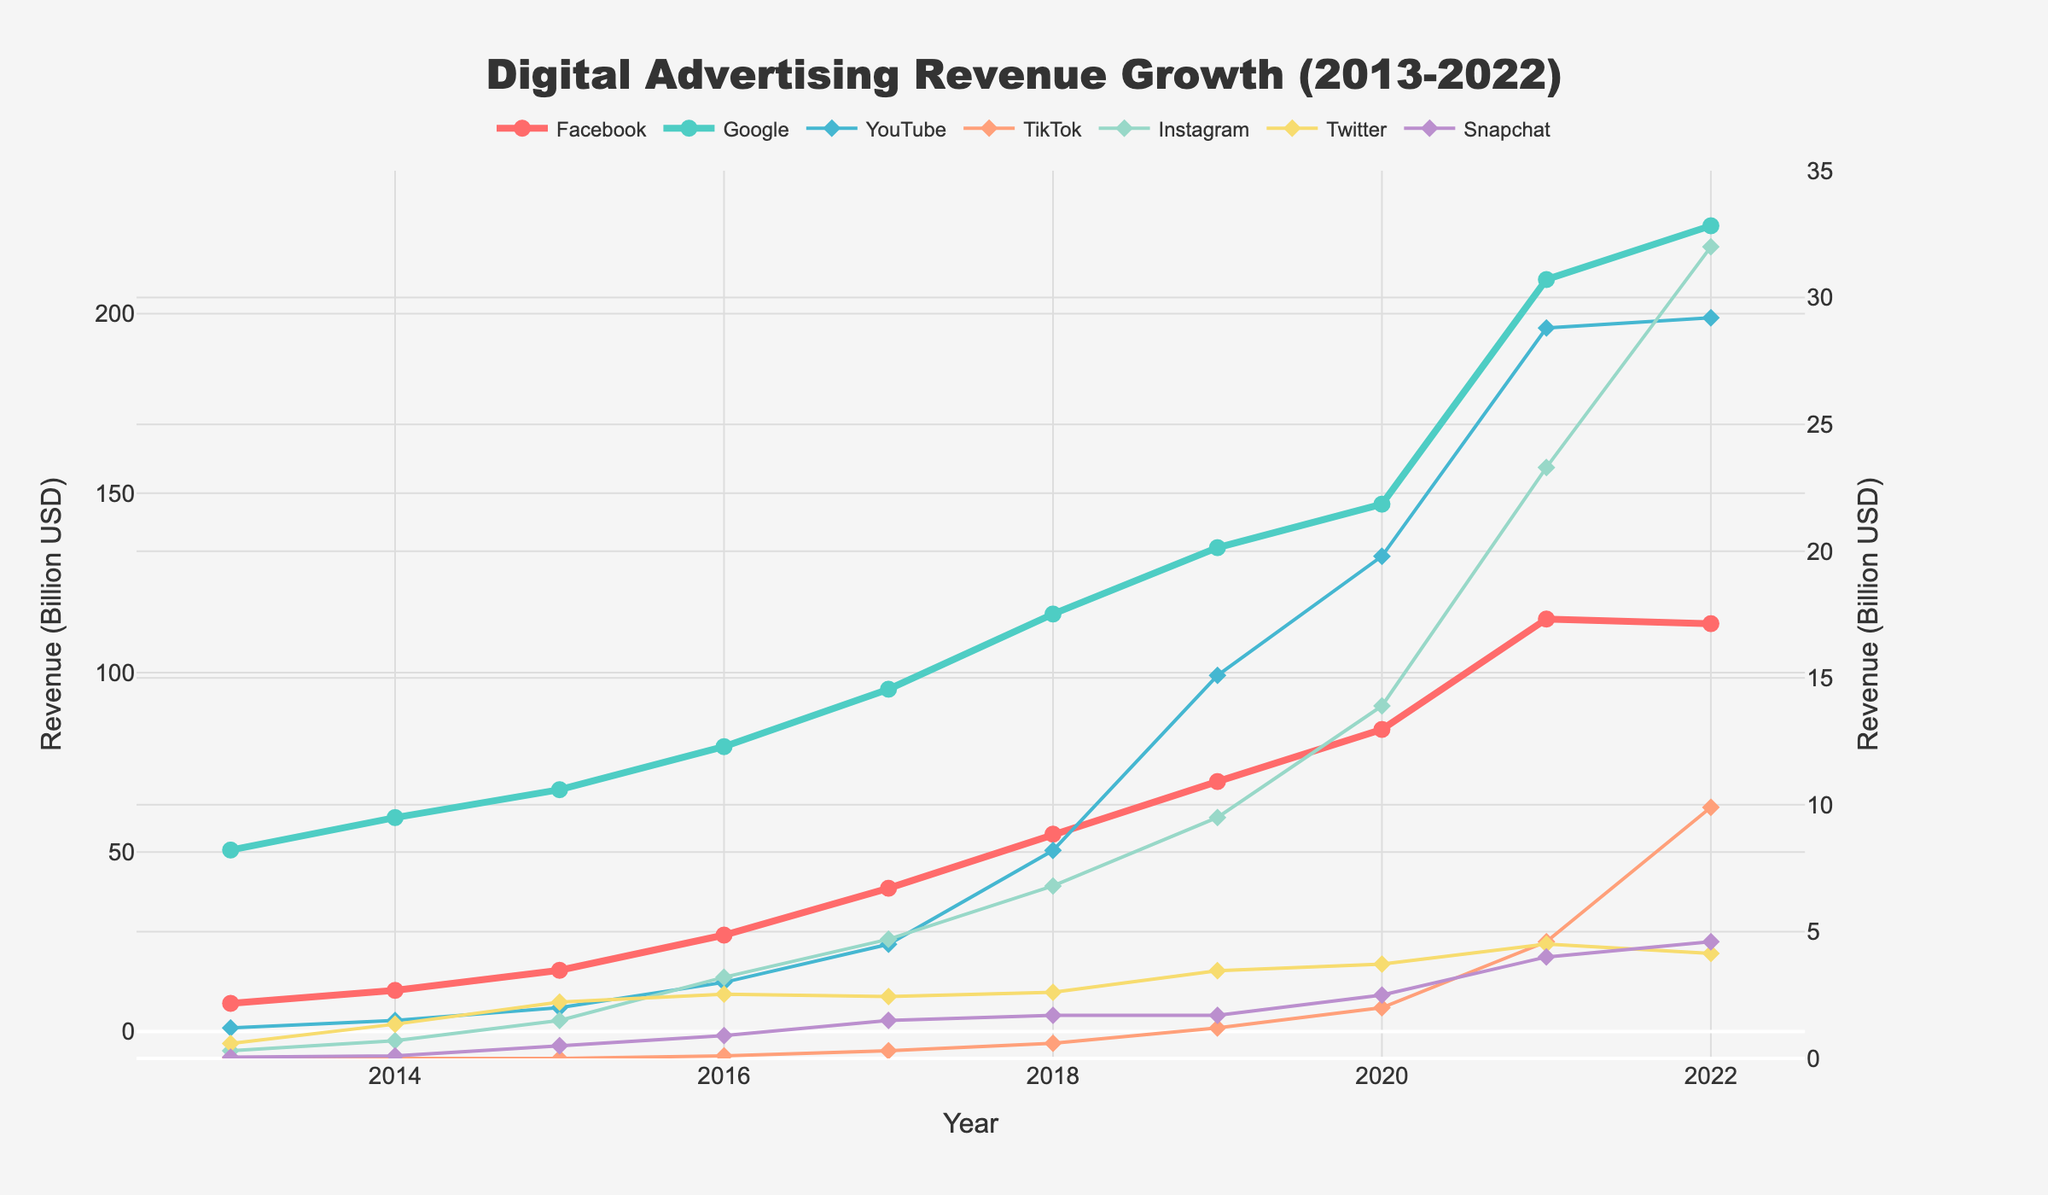Which platform had the highest digital advertising revenue in 2021? Look for the year 2021 on the x-axis and then check which platform has the highest y-value at that point. The highest peak corresponds to Google.
Answer: Google Between which years did Facebook see the highest increase in revenue? Observe the slope of the lines for Facebook; the steepest slope indicates the highest increase, which occurs between 2020 and 2021.
Answer: 2020-2021 What is the difference in revenue between Instagram and TikTok in 2022? Identify the y-values for Instagram and TikTok in 2022 and subtract TikTok's value from Instagram's value. Instagram has approximately 32 billion USD, and TikTok has 9.9 billion USD; the difference is 32 - 9.9.
Answer: 22.1 billion USD In which years did Google's revenue increase less than Facebook's? Compare the slopes of the lines for Google and Facebook for each year. Google's revenue increased less than Facebook's in 2013, 2014, 2015, and 2022.
Answer: 2013, 2014, 2015, 2022 What is the average revenue of Snapchat over the last decade? Sum the revenue values for Snapchat from 2013 to 2022 and divide by the number of years (10). (0.05 + 0.1 + 0.5 + 0.9 + 1.5 + 1.7 + 1.7 + 2.5 + 4.0 + 4.6) / 10 = 1.63 billion USD.
Answer: 1.63 billion USD Which platform showed consistent growth without any drop in revenue from 2013 to 2022? Follow the lines for all platforms and confirm the one that continuously increases. Facebook's line consistently rises throughout the period.
Answer: Facebook By how much did YouTube's revenue grow from 2017 to 2018? Look at YouTube's y-values for 2017 and 2018 and calculate the difference: 8.2 (2018) - 4.5 (2017).
Answer: 3.7 billion USD What was the total revenue for TikTok from 2016 to 2022? Sum the y-values for TikTok from 2016 to 2022 (0.1+0.3+0.6+1.2+2.0+4.6+9.9).
Answer: 18.7 billion USD 